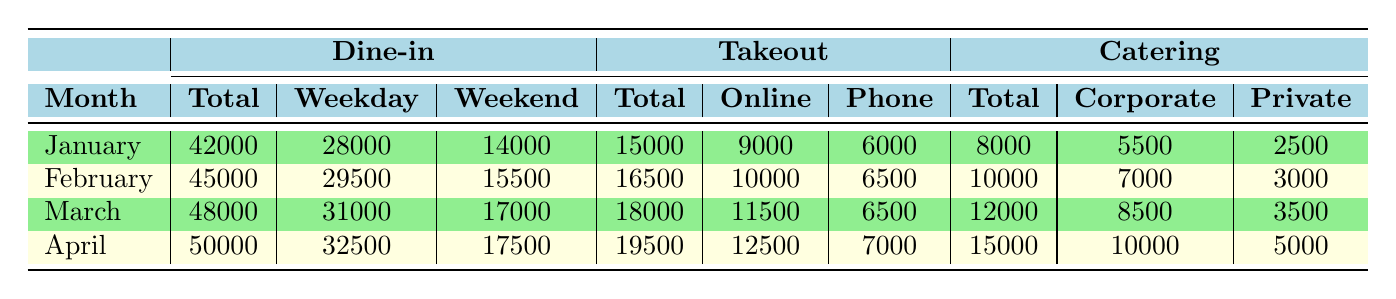What was the total revenue from takeout services in February? According to the table, the total revenue from takeout services in February is listed under the Takeout section and is $16,500.
Answer: $16,500 Which month had the highest revenue from dine-in services? By comparing the total revenues listed under the Dine-in section, April shows the highest total revenue at $50,000.
Answer: April What is the average total revenue from catering services over the four months? The total revenues from catering are: January $8,000, February $10,000, March $12,000, April $15,000. Summing these values gives $8,000 + $10,000 + $12,000 + $15,000 = $45,000, then dividing by 4 results in an average of $45,000 / 4 = $11,250.
Answer: $11,250 Was there a month where the revenue from takeout services was greater than the revenue from catering services? In every month, the total revenue from takeout services is greater than that from catering services. For instance, in January, takeout revenue is $15,000 and catering is $8,000. Thus, the answer is yes.
Answer: Yes What is the difference in total dine-in revenue between March and January? The total dine-in revenue for March is $48,000 and for January is $42,000. The difference is calculated by subtracting January’s revenue from March’s: $48,000 - $42,000 = $6,000.
Answer: $6,000 How much of the takeout revenue in April came from online orders? The table indicates that in April, takeout revenue from online orders is $12,500.
Answer: $12,500 If we consider only weekday dine-in revenue, which month saw the highest earnings? The weekday dine-in revenues for each month are: January $28,000, February $29,500, March $31,000, and April $32,500. April has the highest weekday dine-in revenue of $32,500.
Answer: April If catering corporate events and private parties are combined for March, what is the total revenue? For March, corporate events revenue is $8,500 and private parties revenue is $3,500. Adding these gives $8,500 + $3,500 = $12,000.
Answer: $12,000 In which month did takeout services experience the smallest revenue, and what was that amount? From the takeout totals, January shows the smallest revenue at $15,000 compared to the other months.
Answer: January; $15,000 Is it true that the weekend dine-in revenue increased from January to April? Comparing the weekend revenue for the months: January $14,000, February $15,500, March $17,000, and April $17,500 shows an increase in each month. Thus, the statement is true.
Answer: True 